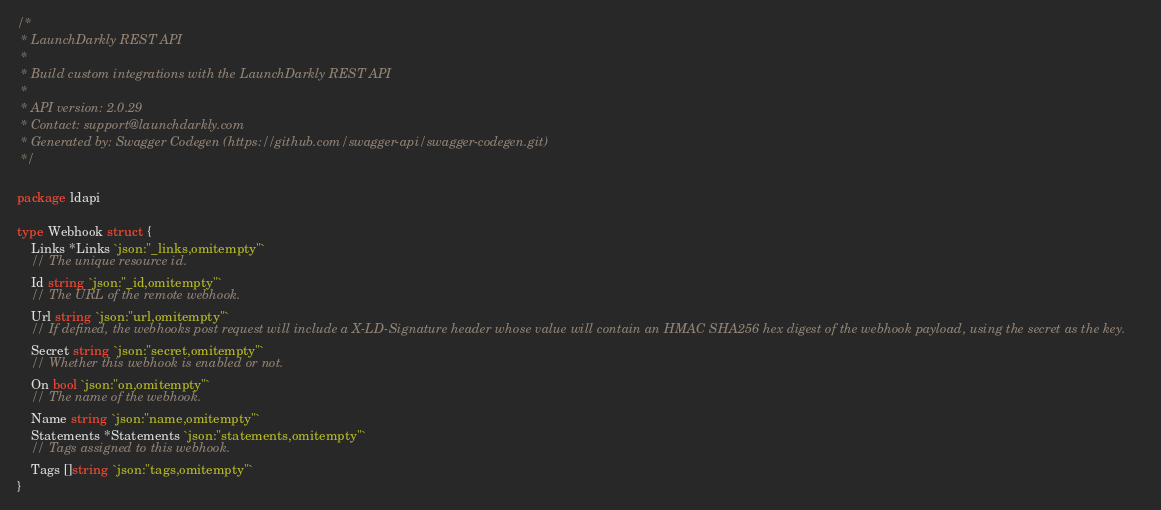Convert code to text. <code><loc_0><loc_0><loc_500><loc_500><_Go_>/*
 * LaunchDarkly REST API
 *
 * Build custom integrations with the LaunchDarkly REST API
 *
 * API version: 2.0.29
 * Contact: support@launchdarkly.com
 * Generated by: Swagger Codegen (https://github.com/swagger-api/swagger-codegen.git)
 */

package ldapi

type Webhook struct {
	Links *Links `json:"_links,omitempty"`
	// The unique resource id.
	Id string `json:"_id,omitempty"`
	// The URL of the remote webhook.
	Url string `json:"url,omitempty"`
	// If defined, the webhooks post request will include a X-LD-Signature header whose value will contain an HMAC SHA256 hex digest of the webhook payload, using the secret as the key.
	Secret string `json:"secret,omitempty"`
	// Whether this webhook is enabled or not.
	On bool `json:"on,omitempty"`
	// The name of the webhook.
	Name string `json:"name,omitempty"`
	Statements *Statements `json:"statements,omitempty"`
	// Tags assigned to this webhook.
	Tags []string `json:"tags,omitempty"`
}
</code> 